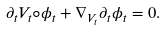Convert formula to latex. <formula><loc_0><loc_0><loc_500><loc_500>\partial _ { t } V _ { t } \circ \phi _ { t } + \nabla _ { V _ { t } } \partial _ { t } \phi _ { t } = 0 .</formula> 